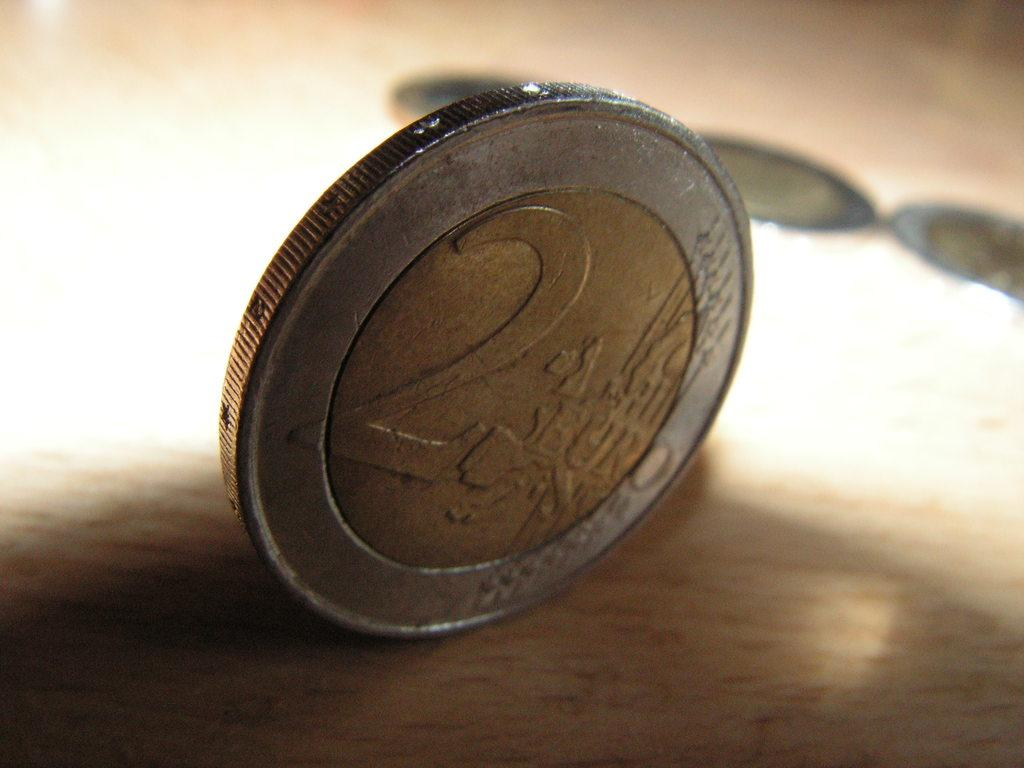<image>
Provide a brief description of the given image. A euro standing upright worth a value of 2 euros 